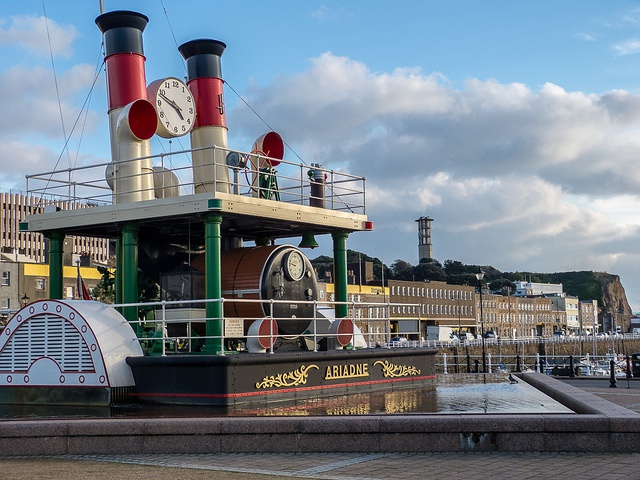Describe the objects in this image and their specific colors. I can see clock in lightblue, lightgray, gray, and darkgray tones and clock in lightblue, beige, tan, black, and gray tones in this image. 